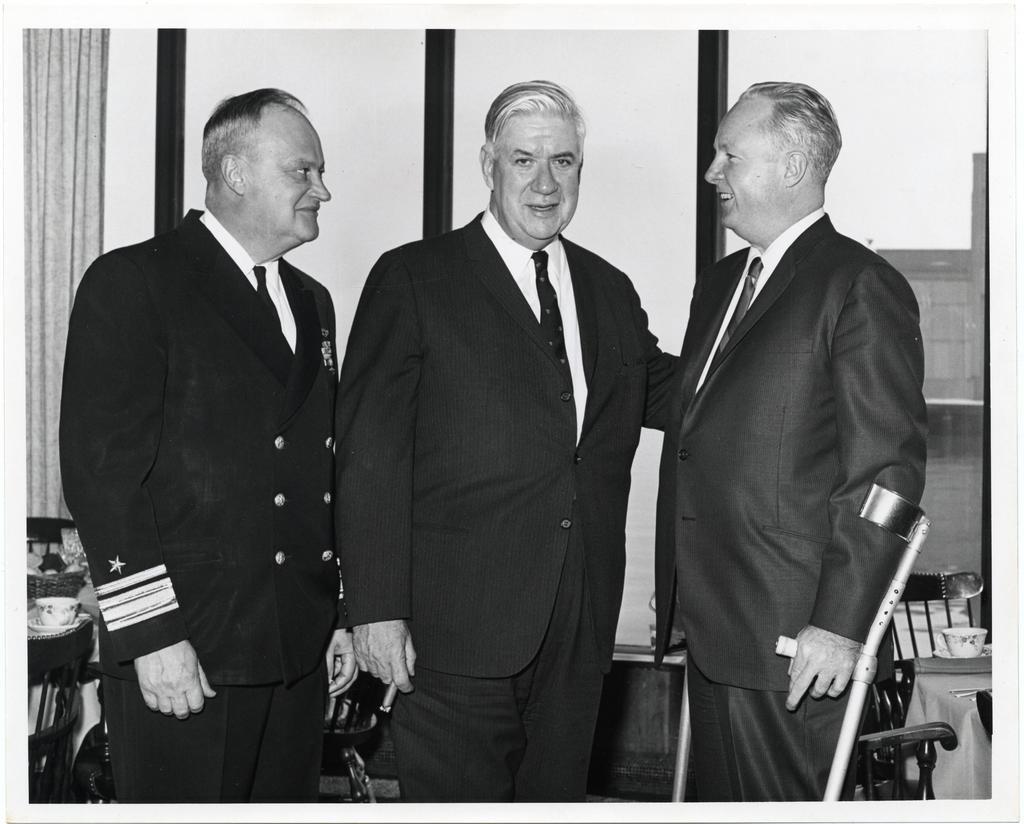Can you describe this image briefly? In the middle of the image three persons are standing and holding sticks and cigarette. Behind them we can see some chairs and tables, on the tables we can see some cups. At the top of the image we can see some glass windows and curtain. 